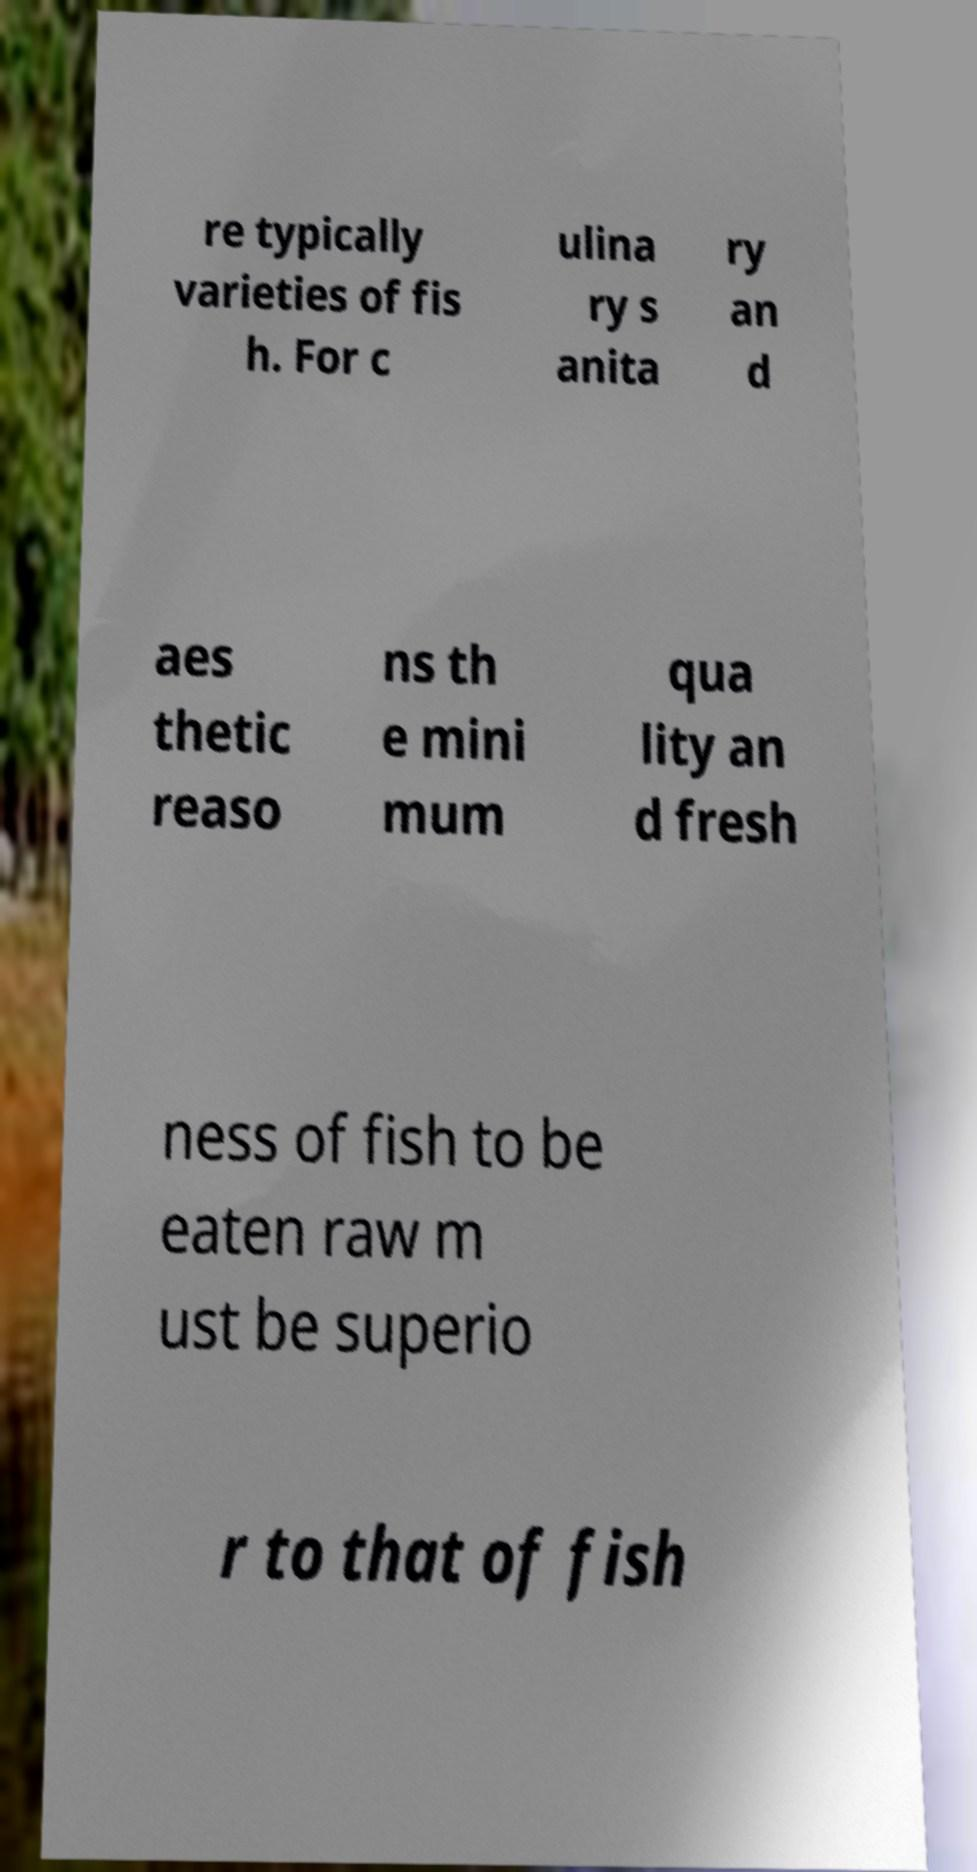Can you accurately transcribe the text from the provided image for me? re typically varieties of fis h. For c ulina ry s anita ry an d aes thetic reaso ns th e mini mum qua lity an d fresh ness of fish to be eaten raw m ust be superio r to that of fish 